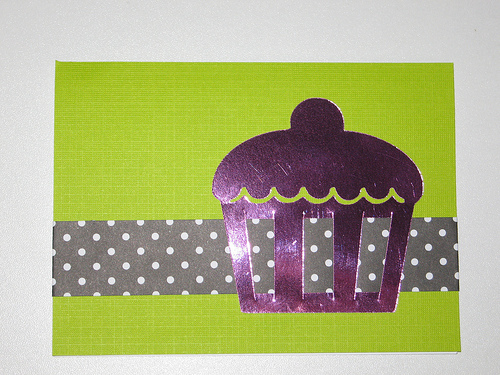<image>
Is there a ribbon in the cupcake? Yes. The ribbon is contained within or inside the cupcake, showing a containment relationship. 